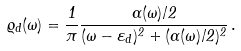<formula> <loc_0><loc_0><loc_500><loc_500>\varrho _ { d } ( \omega ) = \frac { 1 } { \pi } \frac { \Gamma ( \omega ) / 2 } { ( \omega - \varepsilon _ { d } ) ^ { 2 } + ( \Gamma ( \omega ) / 2 ) ^ { 2 } } \, .</formula> 